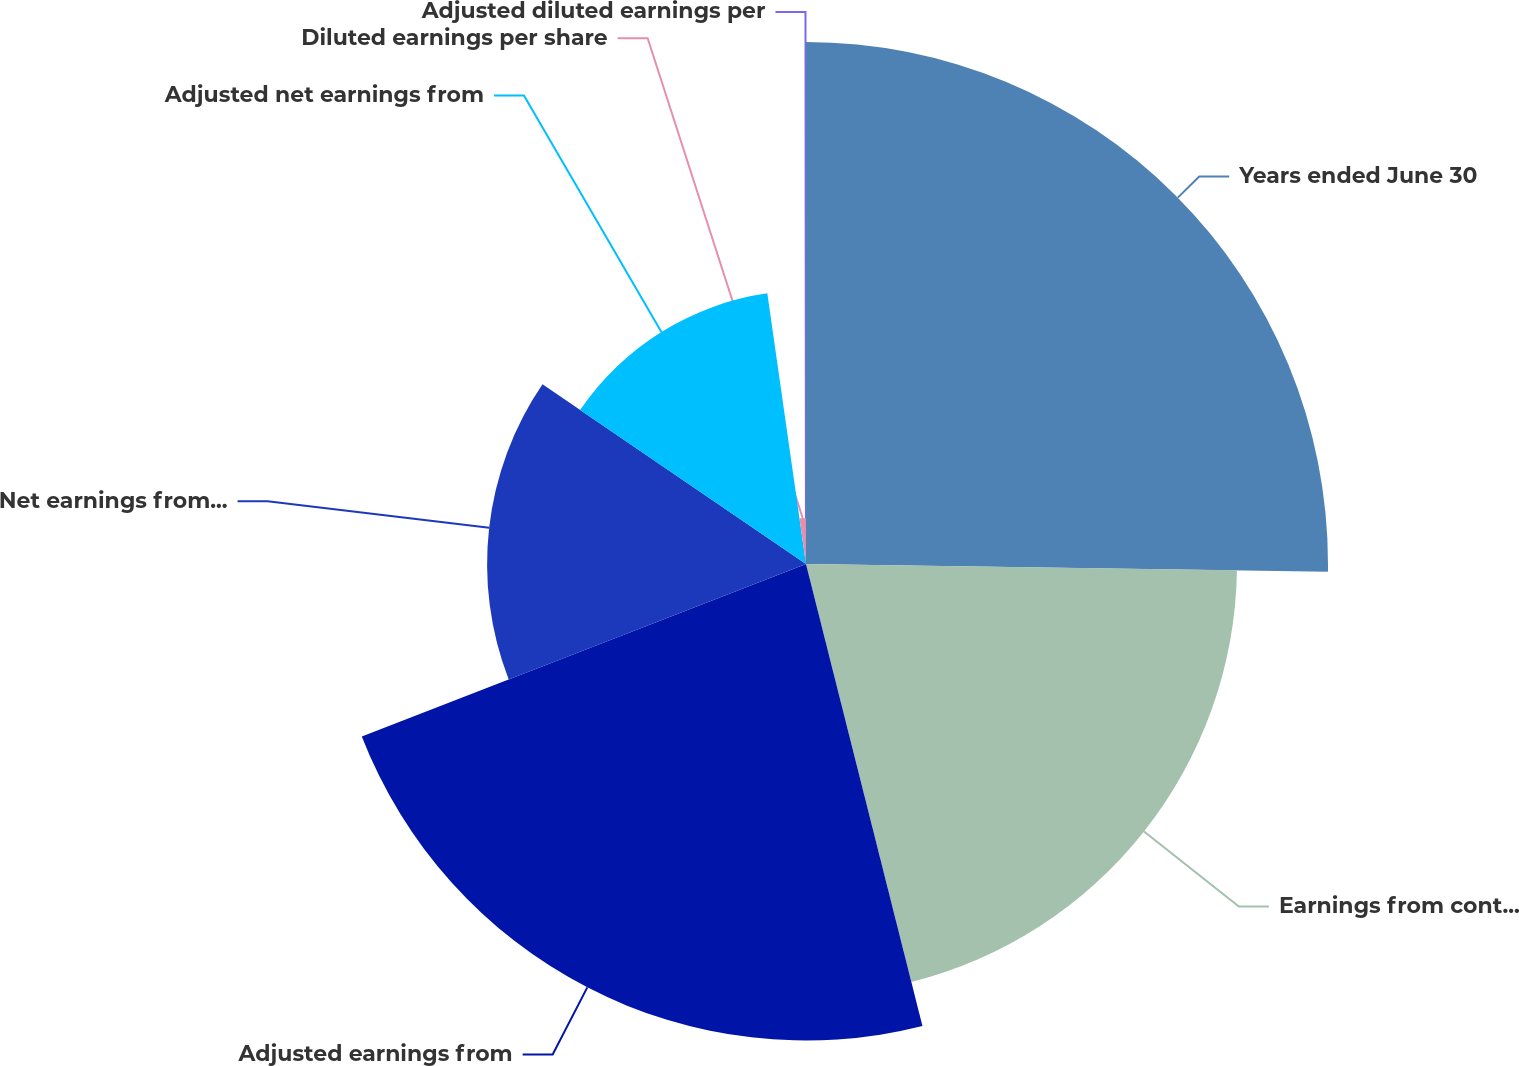<chart> <loc_0><loc_0><loc_500><loc_500><pie_chart><fcel>Years ended June 30<fcel>Earnings from continuing<fcel>Adjusted earnings from<fcel>Net earnings from continuing<fcel>Adjusted net earnings from<fcel>Diluted earnings per share<fcel>Adjusted diluted earnings per<nl><fcel>25.24%<fcel>20.84%<fcel>23.04%<fcel>15.42%<fcel>13.22%<fcel>2.23%<fcel>0.03%<nl></chart> 